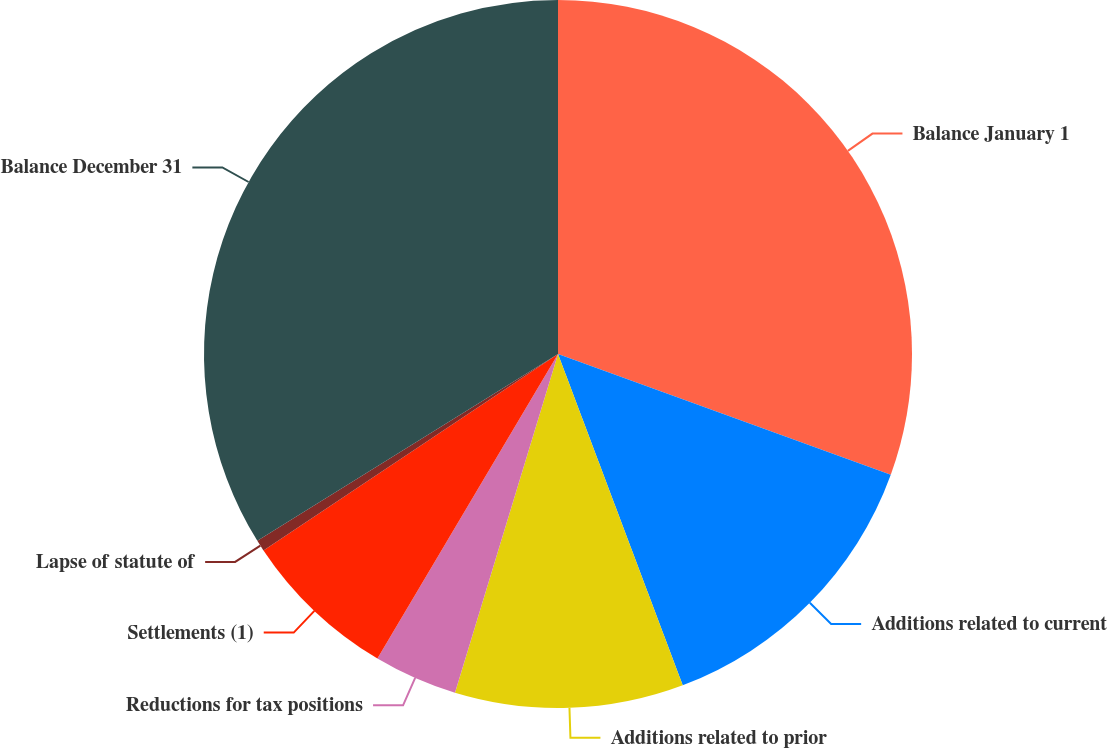Convert chart. <chart><loc_0><loc_0><loc_500><loc_500><pie_chart><fcel>Balance January 1<fcel>Additions related to current<fcel>Additions related to prior<fcel>Reductions for tax positions<fcel>Settlements (1)<fcel>Lapse of statute of<fcel>Balance December 31<nl><fcel>30.54%<fcel>13.73%<fcel>10.43%<fcel>3.82%<fcel>7.12%<fcel>0.51%<fcel>33.85%<nl></chart> 